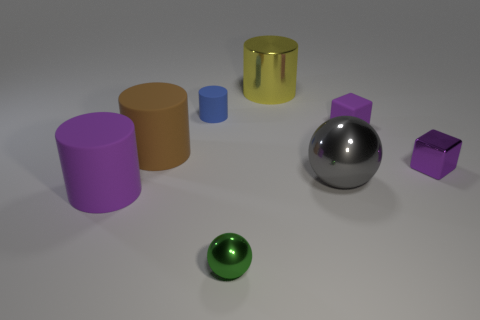What is the material of the other big object that is the same shape as the green metallic thing?
Your answer should be very brief. Metal. What number of brown cylinders are the same size as the yellow cylinder?
Give a very brief answer. 1. What color is the metallic object that is both in front of the tiny metallic block and to the right of the green object?
Provide a succinct answer. Gray. Is the number of purple blocks less than the number of green objects?
Your response must be concise. No. There is a large shiny sphere; does it have the same color as the cylinder in front of the gray metal sphere?
Your answer should be compact. No. Are there the same number of large matte cylinders that are behind the yellow metallic thing and tiny green things that are to the left of the big brown object?
Keep it short and to the point. Yes. How many other gray things are the same shape as the big gray object?
Provide a short and direct response. 0. Are any matte objects visible?
Ensure brevity in your answer.  Yes. Is the material of the blue cylinder the same as the big cylinder that is right of the green sphere?
Give a very brief answer. No. There is a brown thing that is the same size as the gray sphere; what is it made of?
Keep it short and to the point. Rubber. 